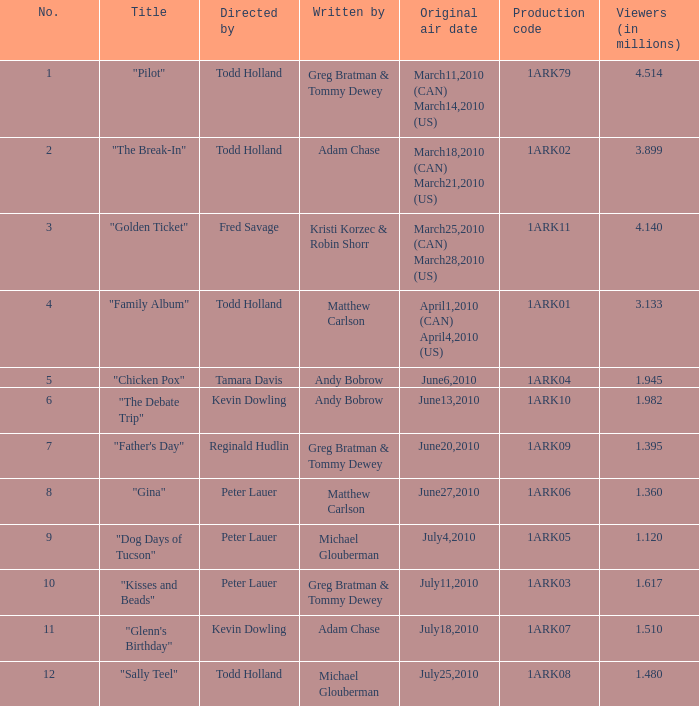What was the number of directors for the production code 1ark08? 1.0. 